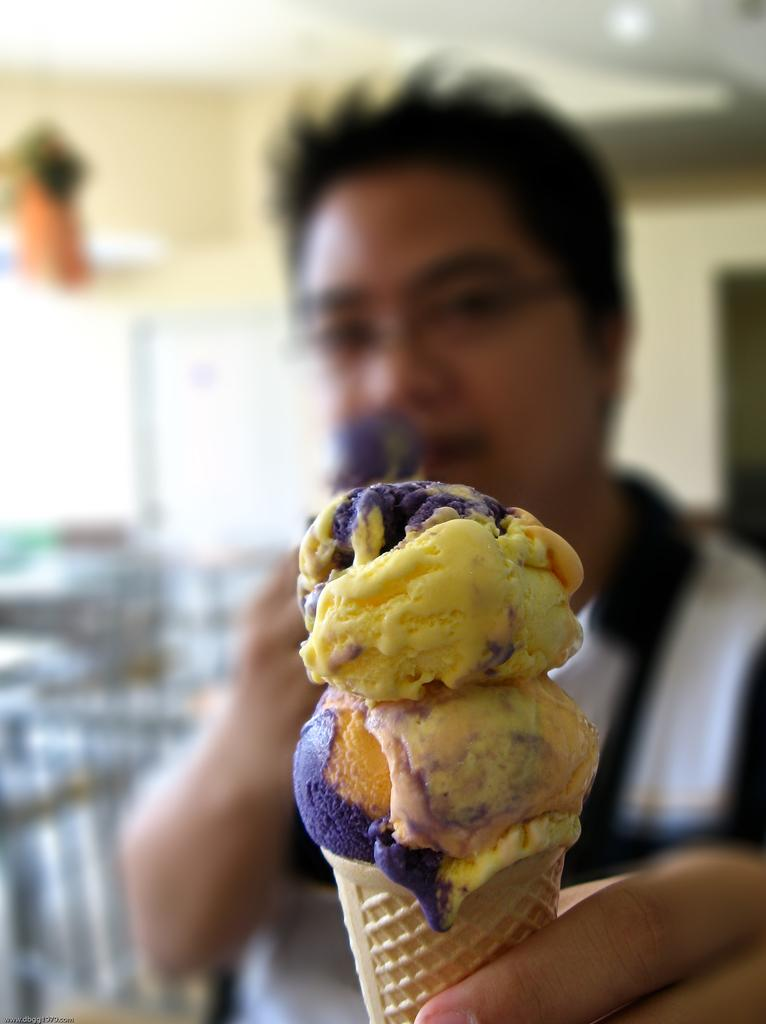Who is present in the image? There is a man in the image. What is the man holding in his hand? The man is holding ice cream in his hand. What can be seen in the background of the image? There are tables and chairs in the background of the image. What is visible above the man in the image? There is a ceiling visible in the image, and there are lights on the ceiling. What type of ship can be seen sailing in the sky in the image? There is no ship visible in the image, nor is there any sky depicted. 